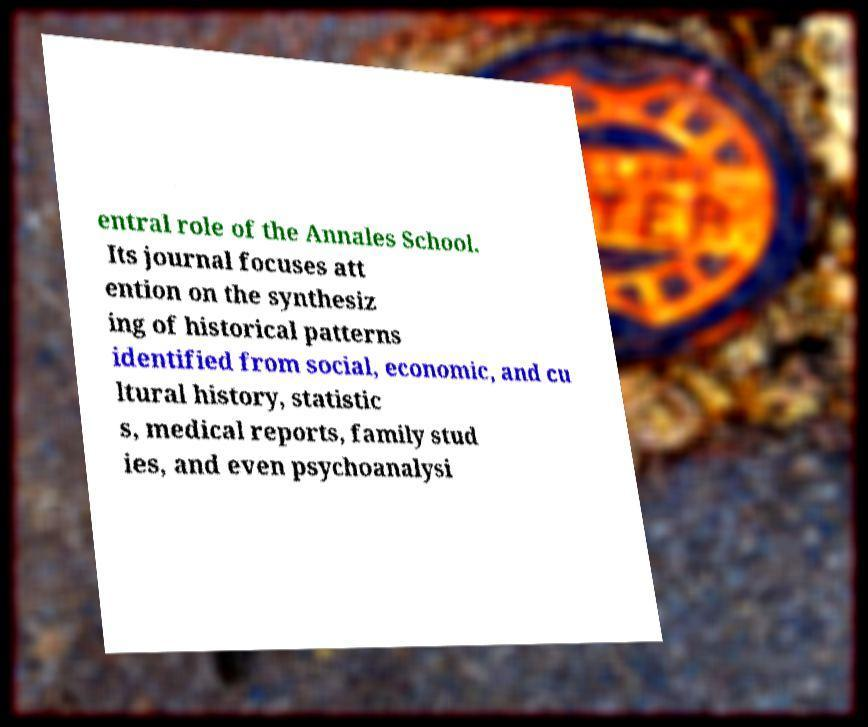Could you assist in decoding the text presented in this image and type it out clearly? entral role of the Annales School. Its journal focuses att ention on the synthesiz ing of historical patterns identified from social, economic, and cu ltural history, statistic s, medical reports, family stud ies, and even psychoanalysi 